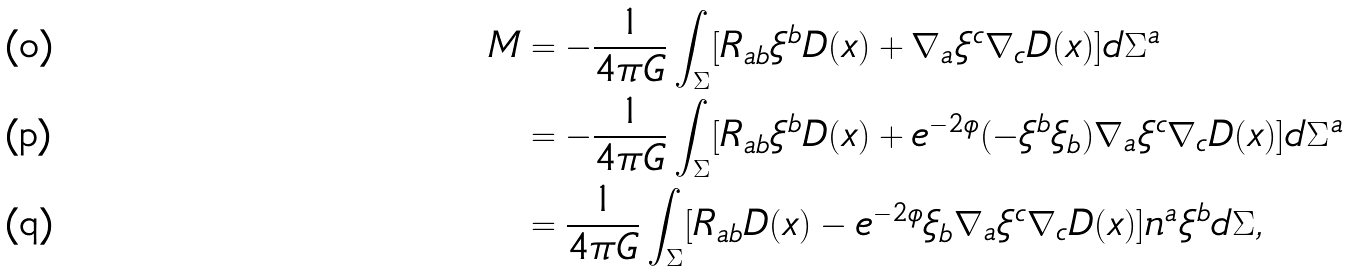<formula> <loc_0><loc_0><loc_500><loc_500>M & = - \frac { 1 } { 4 \pi G } \int _ { \Sigma } [ R _ { a b } \xi ^ { b } D ( x ) + \nabla _ { a } \xi ^ { c } \nabla _ { c } D ( x ) ] d \Sigma ^ { a } \\ & = - \frac { 1 } { 4 \pi G } \int _ { \Sigma } [ R _ { a b } \xi ^ { b } D ( x ) + e ^ { - 2 \phi } ( - \xi ^ { b } \xi _ { b } ) \nabla _ { a } \xi ^ { c } \nabla _ { c } D ( x ) ] d \Sigma ^ { a } \\ & = \frac { 1 } { 4 \pi G } \int _ { \Sigma } [ R _ { a b } D ( x ) - e ^ { - 2 \phi } \xi _ { b } \nabla _ { a } \xi ^ { c } \nabla _ { c } D ( x ) ] n ^ { a } \xi ^ { b } d \Sigma ,</formula> 